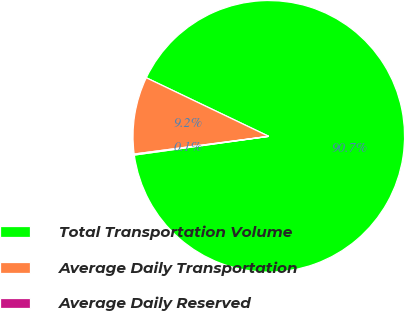Convert chart to OTSL. <chart><loc_0><loc_0><loc_500><loc_500><pie_chart><fcel>Total Transportation Volume<fcel>Average Daily Transportation<fcel>Average Daily Reserved<nl><fcel>90.7%<fcel>9.18%<fcel>0.12%<nl></chart> 